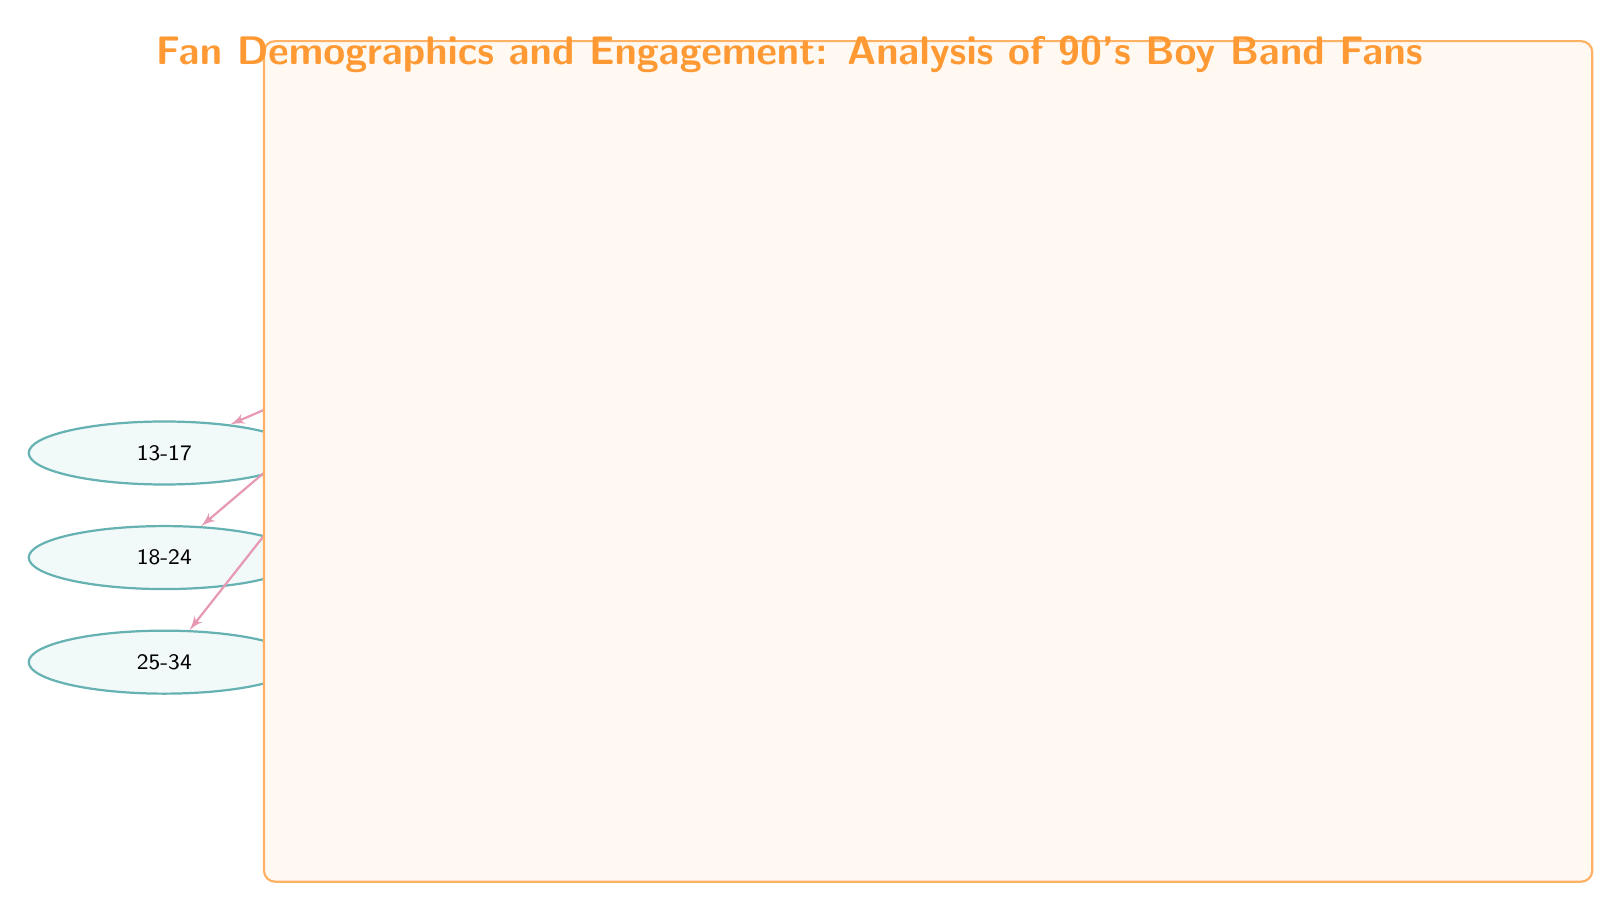What is the main case study shown in the diagram? The diagram prominently features "Excesso Fans in 90s Portugal" as the main case study, indicated within the main node at the top of the diagram.
Answer: Excesso Fans in 90s Portugal How many age groups are represented in the diagram? There are three age groups listed under the "Age Group" node, which are "13-17", "18-24", and "25-34".
Answer: 3 Which gender is represented more in the fan demographic? The diagram has a single "Female" and a single "Male" under the "Fan Gender" node, suggesting equal representation in the fan demographic based on gender.
Answer: Equal What types of engagement are shown in the engagement section? The engagement types include "Concert Attendance", "Merchandise Purchase", "Fan Clubs", and "Online Forums". These are found under the "Engagement Type" node, detailed in sub-nodes below.
Answer: Concert Attendance, Merchandise Purchase, Fan Clubs, Online Forums Which age group is the first listed in the diagram? The first age group listed under the "Age Group" node is "13-17", positioned at the top of the age group sub-nodes.
Answer: 13-17 How does the "Fan Gender" node relate to the main case study? The "Fan Gender" node connects directly to the main node "Case Study: Excesso Fans in 90s Portugal" through a dashed relation line, indicating it is an important factor in the analysis of the case study.
Answer: Direct connection What is the total number of engagement types depicted? The diagram shows four distinct types of engagement under the "Engagement Type" node, which are "Concert Attendance", "Merchandise Purchase", "Fan Clubs", and "Online Forums".
Answer: 4 Which age group appears last in the sequence? The last age group listed in the diagram is "25-34", which is the last of the three age groups below the "Age Group" node.
Answer: 25-34 What color are the main nodes in the diagram? The main nodes are colored purple, as indicated by the style defined for the main node in the diagram's code.
Answer: Purple 